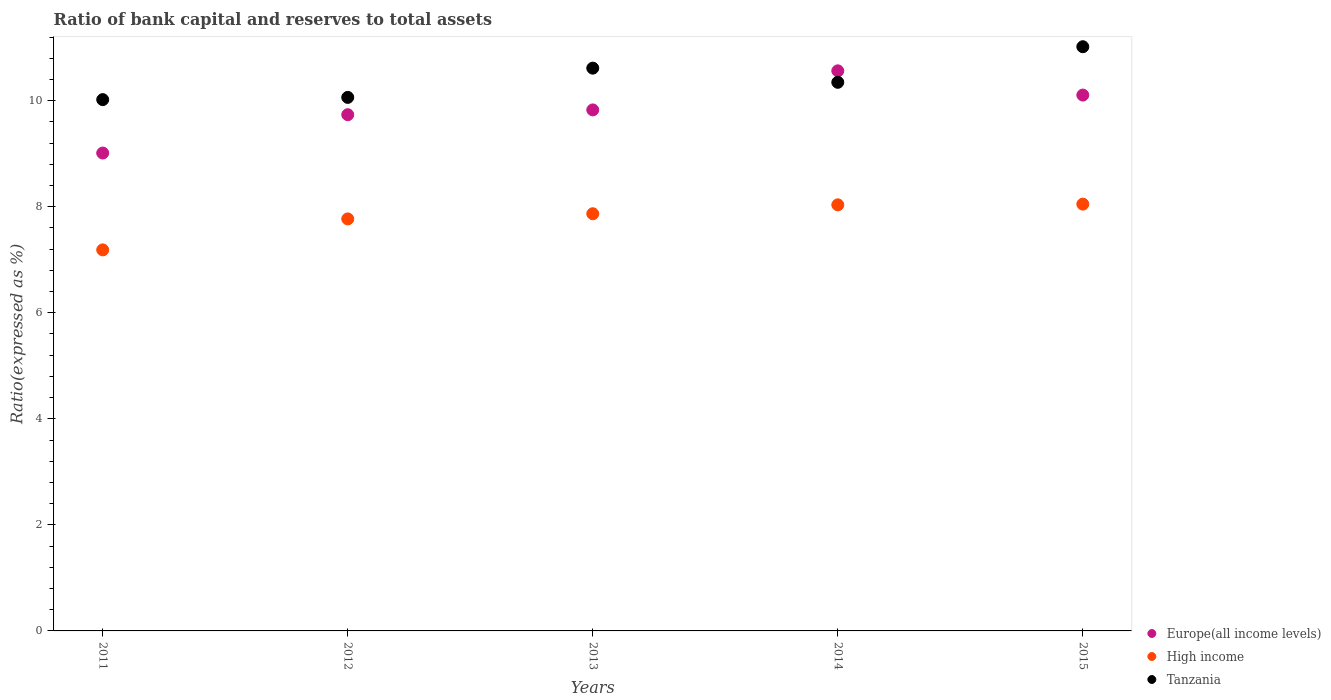What is the ratio of bank capital and reserves to total assets in High income in 2015?
Offer a very short reply. 8.05. Across all years, what is the maximum ratio of bank capital and reserves to total assets in High income?
Your response must be concise. 8.05. Across all years, what is the minimum ratio of bank capital and reserves to total assets in Europe(all income levels)?
Provide a succinct answer. 9.01. In which year was the ratio of bank capital and reserves to total assets in Tanzania maximum?
Your answer should be compact. 2015. What is the total ratio of bank capital and reserves to total assets in Europe(all income levels) in the graph?
Provide a succinct answer. 49.24. What is the difference between the ratio of bank capital and reserves to total assets in High income in 2011 and that in 2015?
Your answer should be compact. -0.86. What is the difference between the ratio of bank capital and reserves to total assets in Europe(all income levels) in 2015 and the ratio of bank capital and reserves to total assets in High income in 2013?
Provide a succinct answer. 2.24. What is the average ratio of bank capital and reserves to total assets in High income per year?
Give a very brief answer. 7.78. In the year 2014, what is the difference between the ratio of bank capital and reserves to total assets in Tanzania and ratio of bank capital and reserves to total assets in High income?
Offer a very short reply. 2.31. What is the ratio of the ratio of bank capital and reserves to total assets in High income in 2014 to that in 2015?
Your answer should be very brief. 1. What is the difference between the highest and the second highest ratio of bank capital and reserves to total assets in Europe(all income levels)?
Keep it short and to the point. 0.46. What is the difference between the highest and the lowest ratio of bank capital and reserves to total assets in Europe(all income levels)?
Offer a very short reply. 1.55. In how many years, is the ratio of bank capital and reserves to total assets in Tanzania greater than the average ratio of bank capital and reserves to total assets in Tanzania taken over all years?
Offer a terse response. 2. Is it the case that in every year, the sum of the ratio of bank capital and reserves to total assets in Tanzania and ratio of bank capital and reserves to total assets in Europe(all income levels)  is greater than the ratio of bank capital and reserves to total assets in High income?
Make the answer very short. Yes. Does the ratio of bank capital and reserves to total assets in High income monotonically increase over the years?
Give a very brief answer. Yes. Is the ratio of bank capital and reserves to total assets in Europe(all income levels) strictly greater than the ratio of bank capital and reserves to total assets in Tanzania over the years?
Your response must be concise. No. What is the difference between two consecutive major ticks on the Y-axis?
Offer a terse response. 2. Are the values on the major ticks of Y-axis written in scientific E-notation?
Give a very brief answer. No. Does the graph contain any zero values?
Your response must be concise. No. Does the graph contain grids?
Your response must be concise. No. Where does the legend appear in the graph?
Your answer should be very brief. Bottom right. How many legend labels are there?
Your answer should be compact. 3. What is the title of the graph?
Your answer should be compact. Ratio of bank capital and reserves to total assets. What is the label or title of the Y-axis?
Ensure brevity in your answer.  Ratio(expressed as %). What is the Ratio(expressed as %) of Europe(all income levels) in 2011?
Keep it short and to the point. 9.01. What is the Ratio(expressed as %) in High income in 2011?
Keep it short and to the point. 7.19. What is the Ratio(expressed as %) in Tanzania in 2011?
Offer a very short reply. 10.02. What is the Ratio(expressed as %) in Europe(all income levels) in 2012?
Provide a succinct answer. 9.74. What is the Ratio(expressed as %) of High income in 2012?
Keep it short and to the point. 7.77. What is the Ratio(expressed as %) of Tanzania in 2012?
Your response must be concise. 10.06. What is the Ratio(expressed as %) in Europe(all income levels) in 2013?
Offer a terse response. 9.83. What is the Ratio(expressed as %) of High income in 2013?
Your answer should be very brief. 7.87. What is the Ratio(expressed as %) of Tanzania in 2013?
Ensure brevity in your answer.  10.61. What is the Ratio(expressed as %) in Europe(all income levels) in 2014?
Offer a very short reply. 10.56. What is the Ratio(expressed as %) of High income in 2014?
Make the answer very short. 8.04. What is the Ratio(expressed as %) in Tanzania in 2014?
Give a very brief answer. 10.35. What is the Ratio(expressed as %) in Europe(all income levels) in 2015?
Make the answer very short. 10.11. What is the Ratio(expressed as %) in High income in 2015?
Offer a very short reply. 8.05. What is the Ratio(expressed as %) in Tanzania in 2015?
Keep it short and to the point. 11.02. Across all years, what is the maximum Ratio(expressed as %) in Europe(all income levels)?
Ensure brevity in your answer.  10.56. Across all years, what is the maximum Ratio(expressed as %) in High income?
Your response must be concise. 8.05. Across all years, what is the maximum Ratio(expressed as %) in Tanzania?
Provide a succinct answer. 11.02. Across all years, what is the minimum Ratio(expressed as %) in Europe(all income levels)?
Keep it short and to the point. 9.01. Across all years, what is the minimum Ratio(expressed as %) in High income?
Ensure brevity in your answer.  7.19. Across all years, what is the minimum Ratio(expressed as %) in Tanzania?
Offer a terse response. 10.02. What is the total Ratio(expressed as %) of Europe(all income levels) in the graph?
Offer a very short reply. 49.24. What is the total Ratio(expressed as %) in High income in the graph?
Offer a very short reply. 38.91. What is the total Ratio(expressed as %) of Tanzania in the graph?
Keep it short and to the point. 52.06. What is the difference between the Ratio(expressed as %) of Europe(all income levels) in 2011 and that in 2012?
Offer a very short reply. -0.72. What is the difference between the Ratio(expressed as %) in High income in 2011 and that in 2012?
Ensure brevity in your answer.  -0.58. What is the difference between the Ratio(expressed as %) in Tanzania in 2011 and that in 2012?
Ensure brevity in your answer.  -0.04. What is the difference between the Ratio(expressed as %) of Europe(all income levels) in 2011 and that in 2013?
Your response must be concise. -0.81. What is the difference between the Ratio(expressed as %) of High income in 2011 and that in 2013?
Your answer should be compact. -0.68. What is the difference between the Ratio(expressed as %) of Tanzania in 2011 and that in 2013?
Make the answer very short. -0.59. What is the difference between the Ratio(expressed as %) of Europe(all income levels) in 2011 and that in 2014?
Provide a succinct answer. -1.55. What is the difference between the Ratio(expressed as %) of High income in 2011 and that in 2014?
Provide a succinct answer. -0.85. What is the difference between the Ratio(expressed as %) of Tanzania in 2011 and that in 2014?
Your response must be concise. -0.33. What is the difference between the Ratio(expressed as %) in Europe(all income levels) in 2011 and that in 2015?
Your answer should be very brief. -1.09. What is the difference between the Ratio(expressed as %) of High income in 2011 and that in 2015?
Give a very brief answer. -0.86. What is the difference between the Ratio(expressed as %) in Tanzania in 2011 and that in 2015?
Provide a succinct answer. -1. What is the difference between the Ratio(expressed as %) in Europe(all income levels) in 2012 and that in 2013?
Your answer should be compact. -0.09. What is the difference between the Ratio(expressed as %) of High income in 2012 and that in 2013?
Ensure brevity in your answer.  -0.1. What is the difference between the Ratio(expressed as %) of Tanzania in 2012 and that in 2013?
Provide a short and direct response. -0.55. What is the difference between the Ratio(expressed as %) of Europe(all income levels) in 2012 and that in 2014?
Keep it short and to the point. -0.83. What is the difference between the Ratio(expressed as %) of High income in 2012 and that in 2014?
Provide a short and direct response. -0.27. What is the difference between the Ratio(expressed as %) in Tanzania in 2012 and that in 2014?
Provide a short and direct response. -0.28. What is the difference between the Ratio(expressed as %) of Europe(all income levels) in 2012 and that in 2015?
Ensure brevity in your answer.  -0.37. What is the difference between the Ratio(expressed as %) of High income in 2012 and that in 2015?
Give a very brief answer. -0.28. What is the difference between the Ratio(expressed as %) in Tanzania in 2012 and that in 2015?
Give a very brief answer. -0.96. What is the difference between the Ratio(expressed as %) of Europe(all income levels) in 2013 and that in 2014?
Your answer should be very brief. -0.74. What is the difference between the Ratio(expressed as %) of High income in 2013 and that in 2014?
Provide a short and direct response. -0.17. What is the difference between the Ratio(expressed as %) in Tanzania in 2013 and that in 2014?
Make the answer very short. 0.27. What is the difference between the Ratio(expressed as %) of Europe(all income levels) in 2013 and that in 2015?
Offer a very short reply. -0.28. What is the difference between the Ratio(expressed as %) of High income in 2013 and that in 2015?
Offer a terse response. -0.18. What is the difference between the Ratio(expressed as %) of Tanzania in 2013 and that in 2015?
Keep it short and to the point. -0.4. What is the difference between the Ratio(expressed as %) of Europe(all income levels) in 2014 and that in 2015?
Give a very brief answer. 0.46. What is the difference between the Ratio(expressed as %) in High income in 2014 and that in 2015?
Your response must be concise. -0.01. What is the difference between the Ratio(expressed as %) of Tanzania in 2014 and that in 2015?
Ensure brevity in your answer.  -0.67. What is the difference between the Ratio(expressed as %) in Europe(all income levels) in 2011 and the Ratio(expressed as %) in High income in 2012?
Ensure brevity in your answer.  1.24. What is the difference between the Ratio(expressed as %) of Europe(all income levels) in 2011 and the Ratio(expressed as %) of Tanzania in 2012?
Your response must be concise. -1.05. What is the difference between the Ratio(expressed as %) in High income in 2011 and the Ratio(expressed as %) in Tanzania in 2012?
Provide a short and direct response. -2.88. What is the difference between the Ratio(expressed as %) in Europe(all income levels) in 2011 and the Ratio(expressed as %) in High income in 2013?
Provide a short and direct response. 1.14. What is the difference between the Ratio(expressed as %) in Europe(all income levels) in 2011 and the Ratio(expressed as %) in Tanzania in 2013?
Give a very brief answer. -1.6. What is the difference between the Ratio(expressed as %) in High income in 2011 and the Ratio(expressed as %) in Tanzania in 2013?
Provide a succinct answer. -3.43. What is the difference between the Ratio(expressed as %) in Europe(all income levels) in 2011 and the Ratio(expressed as %) in High income in 2014?
Give a very brief answer. 0.98. What is the difference between the Ratio(expressed as %) in Europe(all income levels) in 2011 and the Ratio(expressed as %) in Tanzania in 2014?
Make the answer very short. -1.33. What is the difference between the Ratio(expressed as %) of High income in 2011 and the Ratio(expressed as %) of Tanzania in 2014?
Provide a succinct answer. -3.16. What is the difference between the Ratio(expressed as %) in Europe(all income levels) in 2011 and the Ratio(expressed as %) in High income in 2015?
Provide a short and direct response. 0.96. What is the difference between the Ratio(expressed as %) in Europe(all income levels) in 2011 and the Ratio(expressed as %) in Tanzania in 2015?
Ensure brevity in your answer.  -2. What is the difference between the Ratio(expressed as %) in High income in 2011 and the Ratio(expressed as %) in Tanzania in 2015?
Give a very brief answer. -3.83. What is the difference between the Ratio(expressed as %) in Europe(all income levels) in 2012 and the Ratio(expressed as %) in High income in 2013?
Your response must be concise. 1.87. What is the difference between the Ratio(expressed as %) in Europe(all income levels) in 2012 and the Ratio(expressed as %) in Tanzania in 2013?
Keep it short and to the point. -0.88. What is the difference between the Ratio(expressed as %) of High income in 2012 and the Ratio(expressed as %) of Tanzania in 2013?
Your answer should be very brief. -2.84. What is the difference between the Ratio(expressed as %) of Europe(all income levels) in 2012 and the Ratio(expressed as %) of High income in 2014?
Give a very brief answer. 1.7. What is the difference between the Ratio(expressed as %) in Europe(all income levels) in 2012 and the Ratio(expressed as %) in Tanzania in 2014?
Your answer should be very brief. -0.61. What is the difference between the Ratio(expressed as %) of High income in 2012 and the Ratio(expressed as %) of Tanzania in 2014?
Your answer should be compact. -2.58. What is the difference between the Ratio(expressed as %) of Europe(all income levels) in 2012 and the Ratio(expressed as %) of High income in 2015?
Make the answer very short. 1.69. What is the difference between the Ratio(expressed as %) in Europe(all income levels) in 2012 and the Ratio(expressed as %) in Tanzania in 2015?
Offer a very short reply. -1.28. What is the difference between the Ratio(expressed as %) in High income in 2012 and the Ratio(expressed as %) in Tanzania in 2015?
Your answer should be compact. -3.25. What is the difference between the Ratio(expressed as %) of Europe(all income levels) in 2013 and the Ratio(expressed as %) of High income in 2014?
Give a very brief answer. 1.79. What is the difference between the Ratio(expressed as %) in Europe(all income levels) in 2013 and the Ratio(expressed as %) in Tanzania in 2014?
Ensure brevity in your answer.  -0.52. What is the difference between the Ratio(expressed as %) of High income in 2013 and the Ratio(expressed as %) of Tanzania in 2014?
Make the answer very short. -2.48. What is the difference between the Ratio(expressed as %) in Europe(all income levels) in 2013 and the Ratio(expressed as %) in High income in 2015?
Offer a terse response. 1.78. What is the difference between the Ratio(expressed as %) in Europe(all income levels) in 2013 and the Ratio(expressed as %) in Tanzania in 2015?
Provide a short and direct response. -1.19. What is the difference between the Ratio(expressed as %) of High income in 2013 and the Ratio(expressed as %) of Tanzania in 2015?
Keep it short and to the point. -3.15. What is the difference between the Ratio(expressed as %) in Europe(all income levels) in 2014 and the Ratio(expressed as %) in High income in 2015?
Your answer should be compact. 2.51. What is the difference between the Ratio(expressed as %) in Europe(all income levels) in 2014 and the Ratio(expressed as %) in Tanzania in 2015?
Ensure brevity in your answer.  -0.45. What is the difference between the Ratio(expressed as %) of High income in 2014 and the Ratio(expressed as %) of Tanzania in 2015?
Ensure brevity in your answer.  -2.98. What is the average Ratio(expressed as %) of Europe(all income levels) per year?
Keep it short and to the point. 9.85. What is the average Ratio(expressed as %) of High income per year?
Ensure brevity in your answer.  7.78. What is the average Ratio(expressed as %) in Tanzania per year?
Provide a succinct answer. 10.41. In the year 2011, what is the difference between the Ratio(expressed as %) in Europe(all income levels) and Ratio(expressed as %) in High income?
Offer a very short reply. 1.83. In the year 2011, what is the difference between the Ratio(expressed as %) in Europe(all income levels) and Ratio(expressed as %) in Tanzania?
Provide a succinct answer. -1.01. In the year 2011, what is the difference between the Ratio(expressed as %) in High income and Ratio(expressed as %) in Tanzania?
Provide a short and direct response. -2.83. In the year 2012, what is the difference between the Ratio(expressed as %) in Europe(all income levels) and Ratio(expressed as %) in High income?
Offer a terse response. 1.97. In the year 2012, what is the difference between the Ratio(expressed as %) in Europe(all income levels) and Ratio(expressed as %) in Tanzania?
Keep it short and to the point. -0.33. In the year 2012, what is the difference between the Ratio(expressed as %) of High income and Ratio(expressed as %) of Tanzania?
Provide a succinct answer. -2.29. In the year 2013, what is the difference between the Ratio(expressed as %) in Europe(all income levels) and Ratio(expressed as %) in High income?
Your response must be concise. 1.96. In the year 2013, what is the difference between the Ratio(expressed as %) of Europe(all income levels) and Ratio(expressed as %) of Tanzania?
Offer a terse response. -0.79. In the year 2013, what is the difference between the Ratio(expressed as %) in High income and Ratio(expressed as %) in Tanzania?
Make the answer very short. -2.75. In the year 2014, what is the difference between the Ratio(expressed as %) in Europe(all income levels) and Ratio(expressed as %) in High income?
Provide a short and direct response. 2.53. In the year 2014, what is the difference between the Ratio(expressed as %) of Europe(all income levels) and Ratio(expressed as %) of Tanzania?
Give a very brief answer. 0.22. In the year 2014, what is the difference between the Ratio(expressed as %) in High income and Ratio(expressed as %) in Tanzania?
Give a very brief answer. -2.31. In the year 2015, what is the difference between the Ratio(expressed as %) in Europe(all income levels) and Ratio(expressed as %) in High income?
Your answer should be very brief. 2.06. In the year 2015, what is the difference between the Ratio(expressed as %) of Europe(all income levels) and Ratio(expressed as %) of Tanzania?
Offer a terse response. -0.91. In the year 2015, what is the difference between the Ratio(expressed as %) in High income and Ratio(expressed as %) in Tanzania?
Your answer should be very brief. -2.97. What is the ratio of the Ratio(expressed as %) of Europe(all income levels) in 2011 to that in 2012?
Provide a short and direct response. 0.93. What is the ratio of the Ratio(expressed as %) in High income in 2011 to that in 2012?
Give a very brief answer. 0.92. What is the ratio of the Ratio(expressed as %) in Tanzania in 2011 to that in 2012?
Offer a terse response. 1. What is the ratio of the Ratio(expressed as %) of Europe(all income levels) in 2011 to that in 2013?
Your answer should be very brief. 0.92. What is the ratio of the Ratio(expressed as %) in High income in 2011 to that in 2013?
Provide a succinct answer. 0.91. What is the ratio of the Ratio(expressed as %) in Tanzania in 2011 to that in 2013?
Provide a succinct answer. 0.94. What is the ratio of the Ratio(expressed as %) of Europe(all income levels) in 2011 to that in 2014?
Ensure brevity in your answer.  0.85. What is the ratio of the Ratio(expressed as %) of High income in 2011 to that in 2014?
Provide a short and direct response. 0.89. What is the ratio of the Ratio(expressed as %) in Tanzania in 2011 to that in 2014?
Keep it short and to the point. 0.97. What is the ratio of the Ratio(expressed as %) in Europe(all income levels) in 2011 to that in 2015?
Ensure brevity in your answer.  0.89. What is the ratio of the Ratio(expressed as %) of High income in 2011 to that in 2015?
Provide a succinct answer. 0.89. What is the ratio of the Ratio(expressed as %) in Tanzania in 2011 to that in 2015?
Offer a very short reply. 0.91. What is the ratio of the Ratio(expressed as %) in Europe(all income levels) in 2012 to that in 2013?
Your response must be concise. 0.99. What is the ratio of the Ratio(expressed as %) of High income in 2012 to that in 2013?
Offer a very short reply. 0.99. What is the ratio of the Ratio(expressed as %) of Tanzania in 2012 to that in 2013?
Make the answer very short. 0.95. What is the ratio of the Ratio(expressed as %) of Europe(all income levels) in 2012 to that in 2014?
Your answer should be compact. 0.92. What is the ratio of the Ratio(expressed as %) of High income in 2012 to that in 2014?
Your answer should be very brief. 0.97. What is the ratio of the Ratio(expressed as %) of Tanzania in 2012 to that in 2014?
Make the answer very short. 0.97. What is the ratio of the Ratio(expressed as %) in Europe(all income levels) in 2012 to that in 2015?
Provide a succinct answer. 0.96. What is the ratio of the Ratio(expressed as %) in High income in 2012 to that in 2015?
Keep it short and to the point. 0.97. What is the ratio of the Ratio(expressed as %) in Tanzania in 2012 to that in 2015?
Give a very brief answer. 0.91. What is the ratio of the Ratio(expressed as %) in Europe(all income levels) in 2013 to that in 2014?
Make the answer very short. 0.93. What is the ratio of the Ratio(expressed as %) in High income in 2013 to that in 2014?
Keep it short and to the point. 0.98. What is the ratio of the Ratio(expressed as %) of Tanzania in 2013 to that in 2014?
Offer a very short reply. 1.03. What is the ratio of the Ratio(expressed as %) of Europe(all income levels) in 2013 to that in 2015?
Your answer should be compact. 0.97. What is the ratio of the Ratio(expressed as %) of High income in 2013 to that in 2015?
Ensure brevity in your answer.  0.98. What is the ratio of the Ratio(expressed as %) in Tanzania in 2013 to that in 2015?
Keep it short and to the point. 0.96. What is the ratio of the Ratio(expressed as %) in Europe(all income levels) in 2014 to that in 2015?
Your answer should be compact. 1.05. What is the ratio of the Ratio(expressed as %) in Tanzania in 2014 to that in 2015?
Your response must be concise. 0.94. What is the difference between the highest and the second highest Ratio(expressed as %) of Europe(all income levels)?
Your answer should be compact. 0.46. What is the difference between the highest and the second highest Ratio(expressed as %) in High income?
Give a very brief answer. 0.01. What is the difference between the highest and the second highest Ratio(expressed as %) in Tanzania?
Keep it short and to the point. 0.4. What is the difference between the highest and the lowest Ratio(expressed as %) in Europe(all income levels)?
Give a very brief answer. 1.55. What is the difference between the highest and the lowest Ratio(expressed as %) of High income?
Provide a succinct answer. 0.86. 